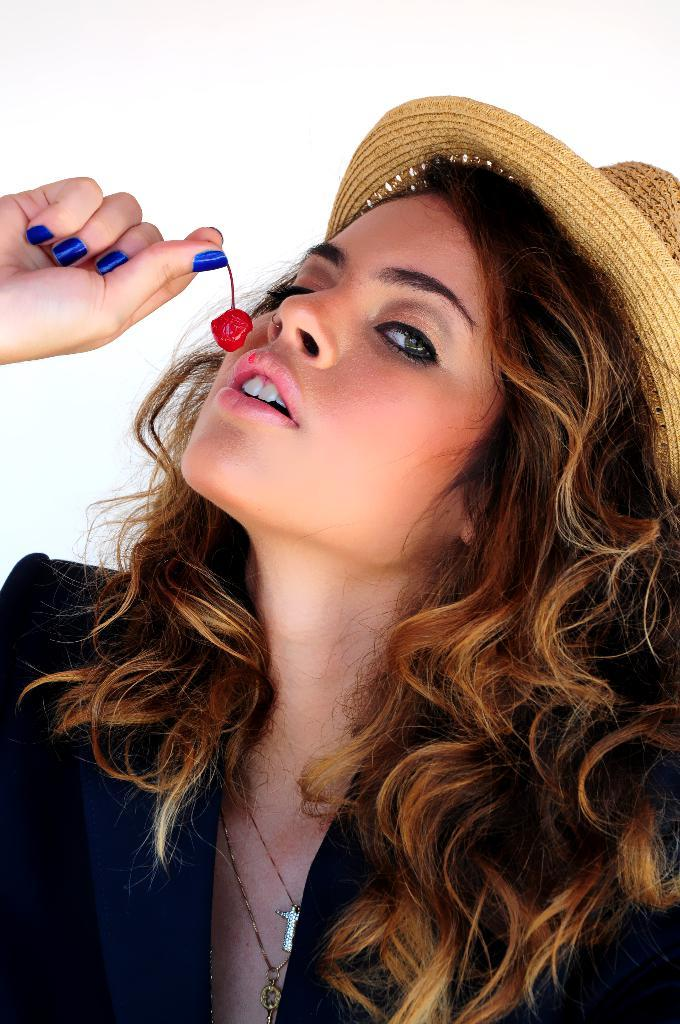Who is the main subject in the image? There is a girl in the image. What is the girl wearing on her head? The girl is wearing a hat. What object is the girl holding in her hand? The girl is holding a cherry. Where is the cherry positioned in relation to the girl's mouth? The cherry is in front of her mouth. What type of slope can be seen in the image? There is no slope present in the image. How many pears are visible in the image? There are no pears visible in the image. 